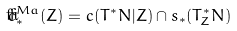Convert formula to latex. <formula><loc_0><loc_0><loc_500><loc_500>\check { c } ^ { M a } _ { * } ( Z ) = c ( T ^ { * } N | Z ) \cap s _ { * } ( T _ { Z } ^ { * } N )</formula> 